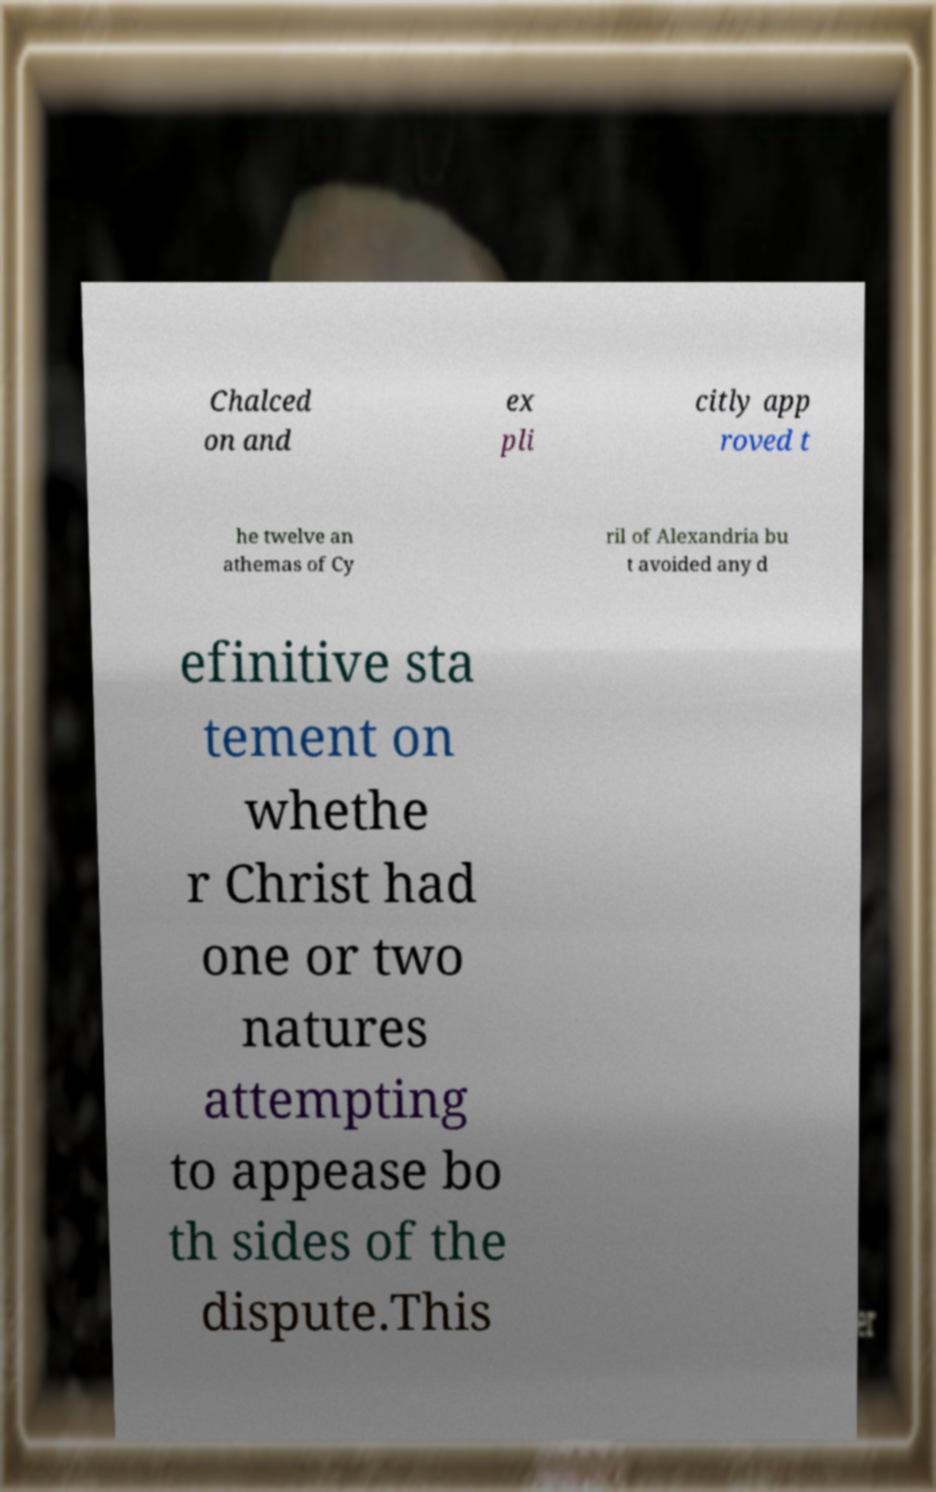For documentation purposes, I need the text within this image transcribed. Could you provide that? Chalced on and ex pli citly app roved t he twelve an athemas of Cy ril of Alexandria bu t avoided any d efinitive sta tement on whethe r Christ had one or two natures attempting to appease bo th sides of the dispute.This 